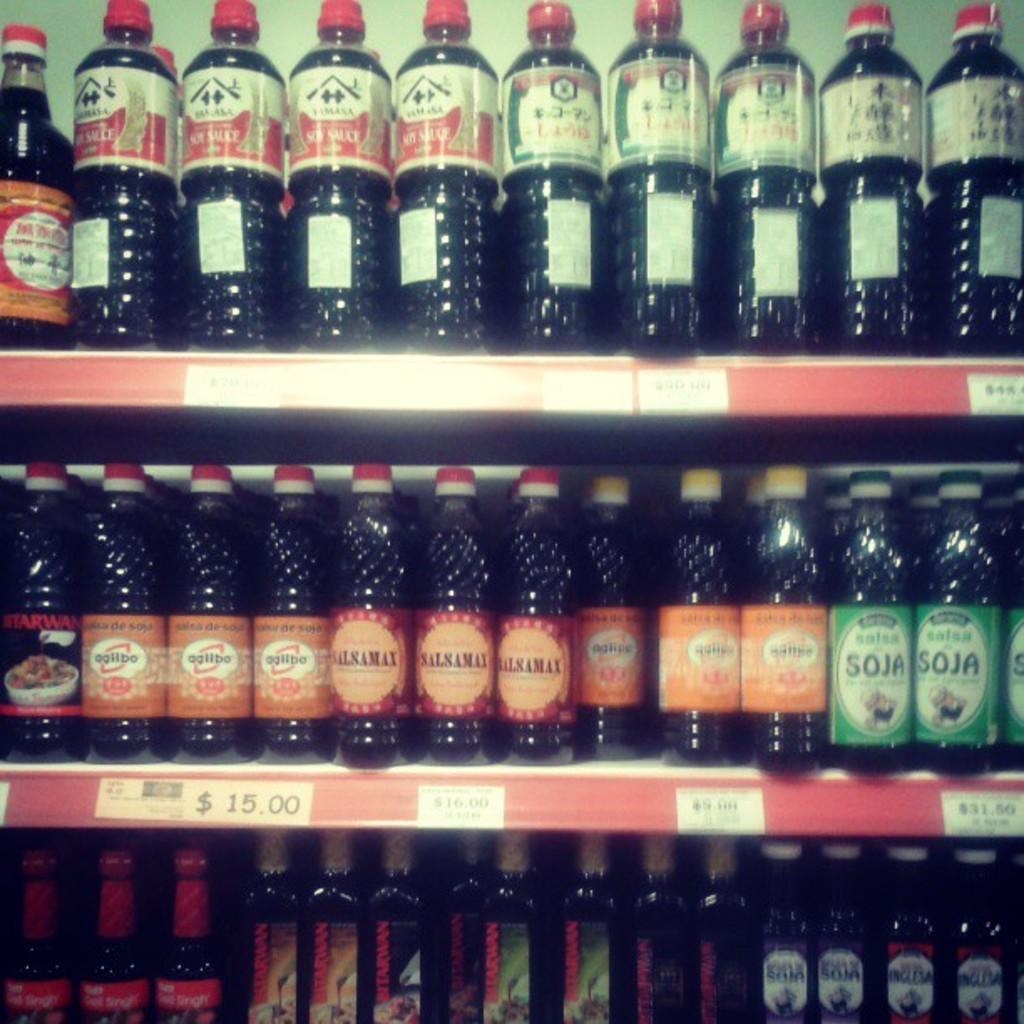<image>
Create a compact narrative representing the image presented. many soy and salsamax bottles on a shelf 